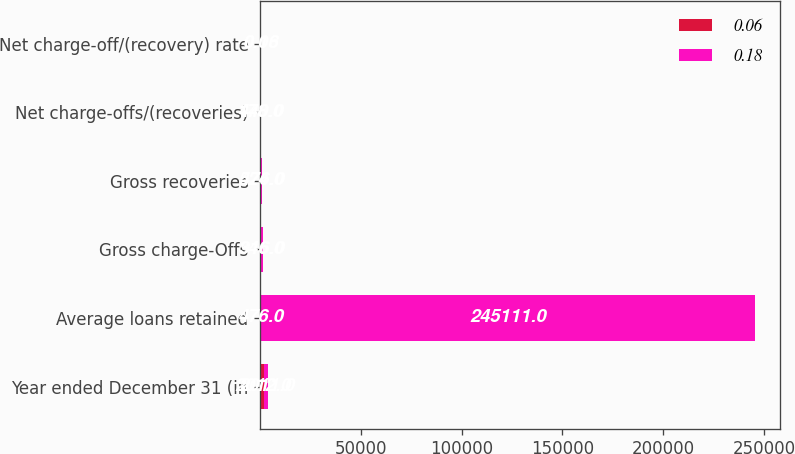<chart> <loc_0><loc_0><loc_500><loc_500><stacked_bar_chart><ecel><fcel>Year ended December 31 (in<fcel>Average loans retained<fcel>Gross charge-Offs<fcel>Gross recoveries<fcel>Net charge-offs/(recoveries)<fcel>Net charge-off/(recovery) rate<nl><fcel>0.06<fcel>2012<fcel>476<fcel>346<fcel>524<fcel>178<fcel>0.06<nl><fcel>0.18<fcel>2011<fcel>245111<fcel>916<fcel>476<fcel>440<fcel>0.18<nl></chart> 